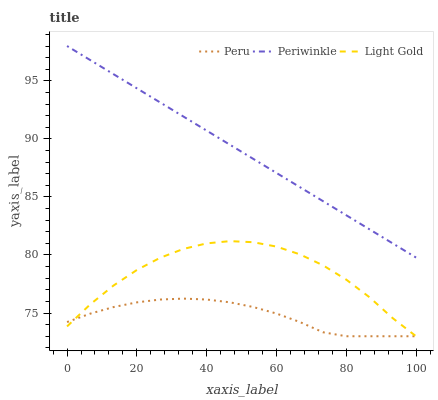Does Peru have the minimum area under the curve?
Answer yes or no. Yes. Does Periwinkle have the maximum area under the curve?
Answer yes or no. Yes. Does Periwinkle have the minimum area under the curve?
Answer yes or no. No. Does Peru have the maximum area under the curve?
Answer yes or no. No. Is Periwinkle the smoothest?
Answer yes or no. Yes. Is Light Gold the roughest?
Answer yes or no. Yes. Is Peru the smoothest?
Answer yes or no. No. Is Peru the roughest?
Answer yes or no. No. Does Periwinkle have the lowest value?
Answer yes or no. No. Does Periwinkle have the highest value?
Answer yes or no. Yes. Does Peru have the highest value?
Answer yes or no. No. Is Light Gold less than Periwinkle?
Answer yes or no. Yes. Is Periwinkle greater than Light Gold?
Answer yes or no. Yes. Does Peru intersect Light Gold?
Answer yes or no. Yes. Is Peru less than Light Gold?
Answer yes or no. No. Is Peru greater than Light Gold?
Answer yes or no. No. Does Light Gold intersect Periwinkle?
Answer yes or no. No. 